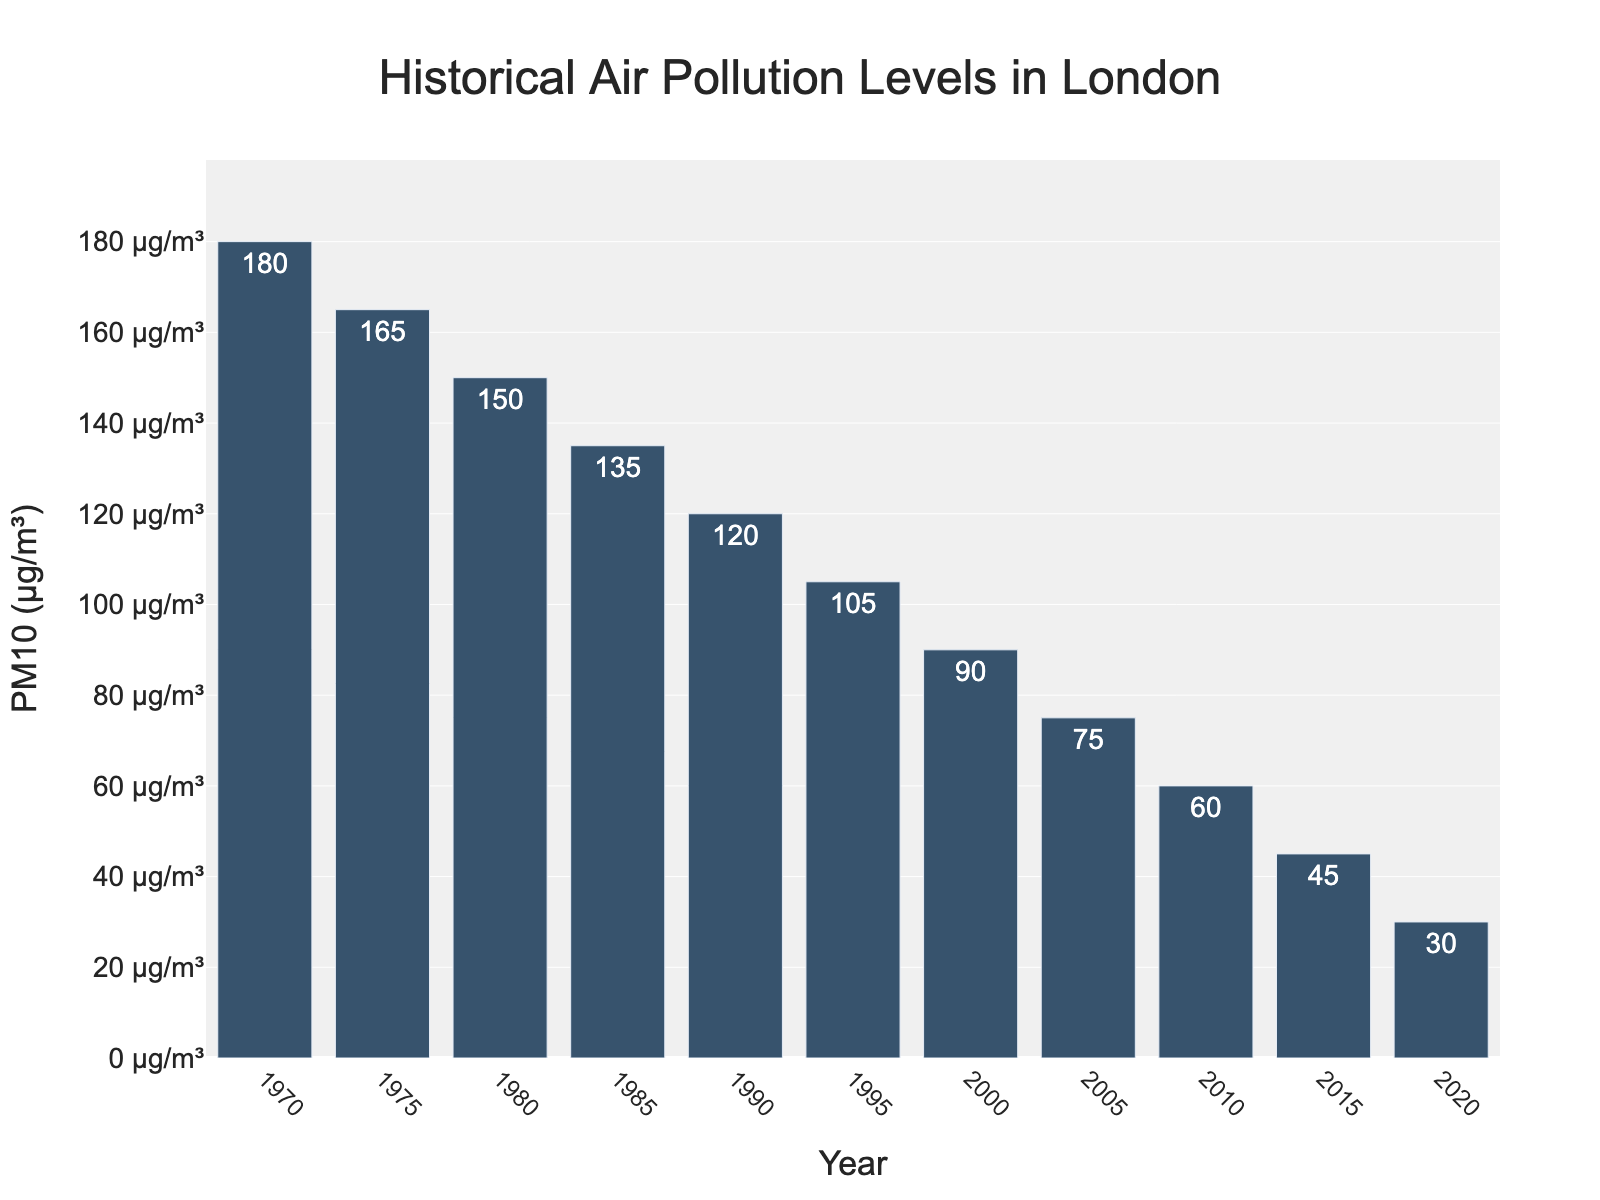What was the PM10 level in 1985? Find the bar corresponding to the year 1985 and read the height, which shows the PM10 level.
Answer: 135 µg/m³ Which year had the highest level of PM10? Look for the tallest bar in the chart, which corresponds to the year with the highest PM10 level.
Answer: 1970 How much did the PM10 level decrease from 1970 to 2020? Subtract the PM10 level in 2020 from the PM10 level in 1970. (180 µg/m³ - 30 µg/m³)
Answer: 150 µg/m³ What is the average PM10 level for the years shown in the figure? Sum all the PM10 levels from each year and divide by the number of years. [(180 + 165 + 150 + 135 + 120 + 105 + 90 + 75 + 60 + 45 + 30) / 11]
Answer: 105 µg/m³ In which decade did the PM10 levels decrease by the largest amount? Calculate the decrease for each decade and compare the values. For example, (1970-1980): 180 - 150 = 30, (2000-2010): 90 - 60 = 30, then identify the largest decrease.
Answer: 1970s (30 µg/m³) By what percentage did the PM10 levels decrease from 2000 to 2020? Use the formula [(initial value - final value) / initial value] * 100 to find the percentage decrease. [(90 - 30) / 90] * 100
Answer: 66.67% Did the PM10 level decrease more from 1970 to 1980 or from 1980 to 1990? Calculate the decrease for each period and compare. (1970 to 1980): 180 - 150 = 30, (1980 to 1990): 150 - 120 = 30.
Answer: Equal decrease (30 µg/m³) What is the trend of the PM10 levels over the decades? Observe that the height of the bars generally decreases as you go from left to right, indicating a downward trend.
Answer: Decreasing trend By what amount did the PM10 levels decrease on average per decade? Calculate the total decrease and divide by the number of decades. [(180 - 30) / 5]
Answer: 30 µg/m³ per decade 